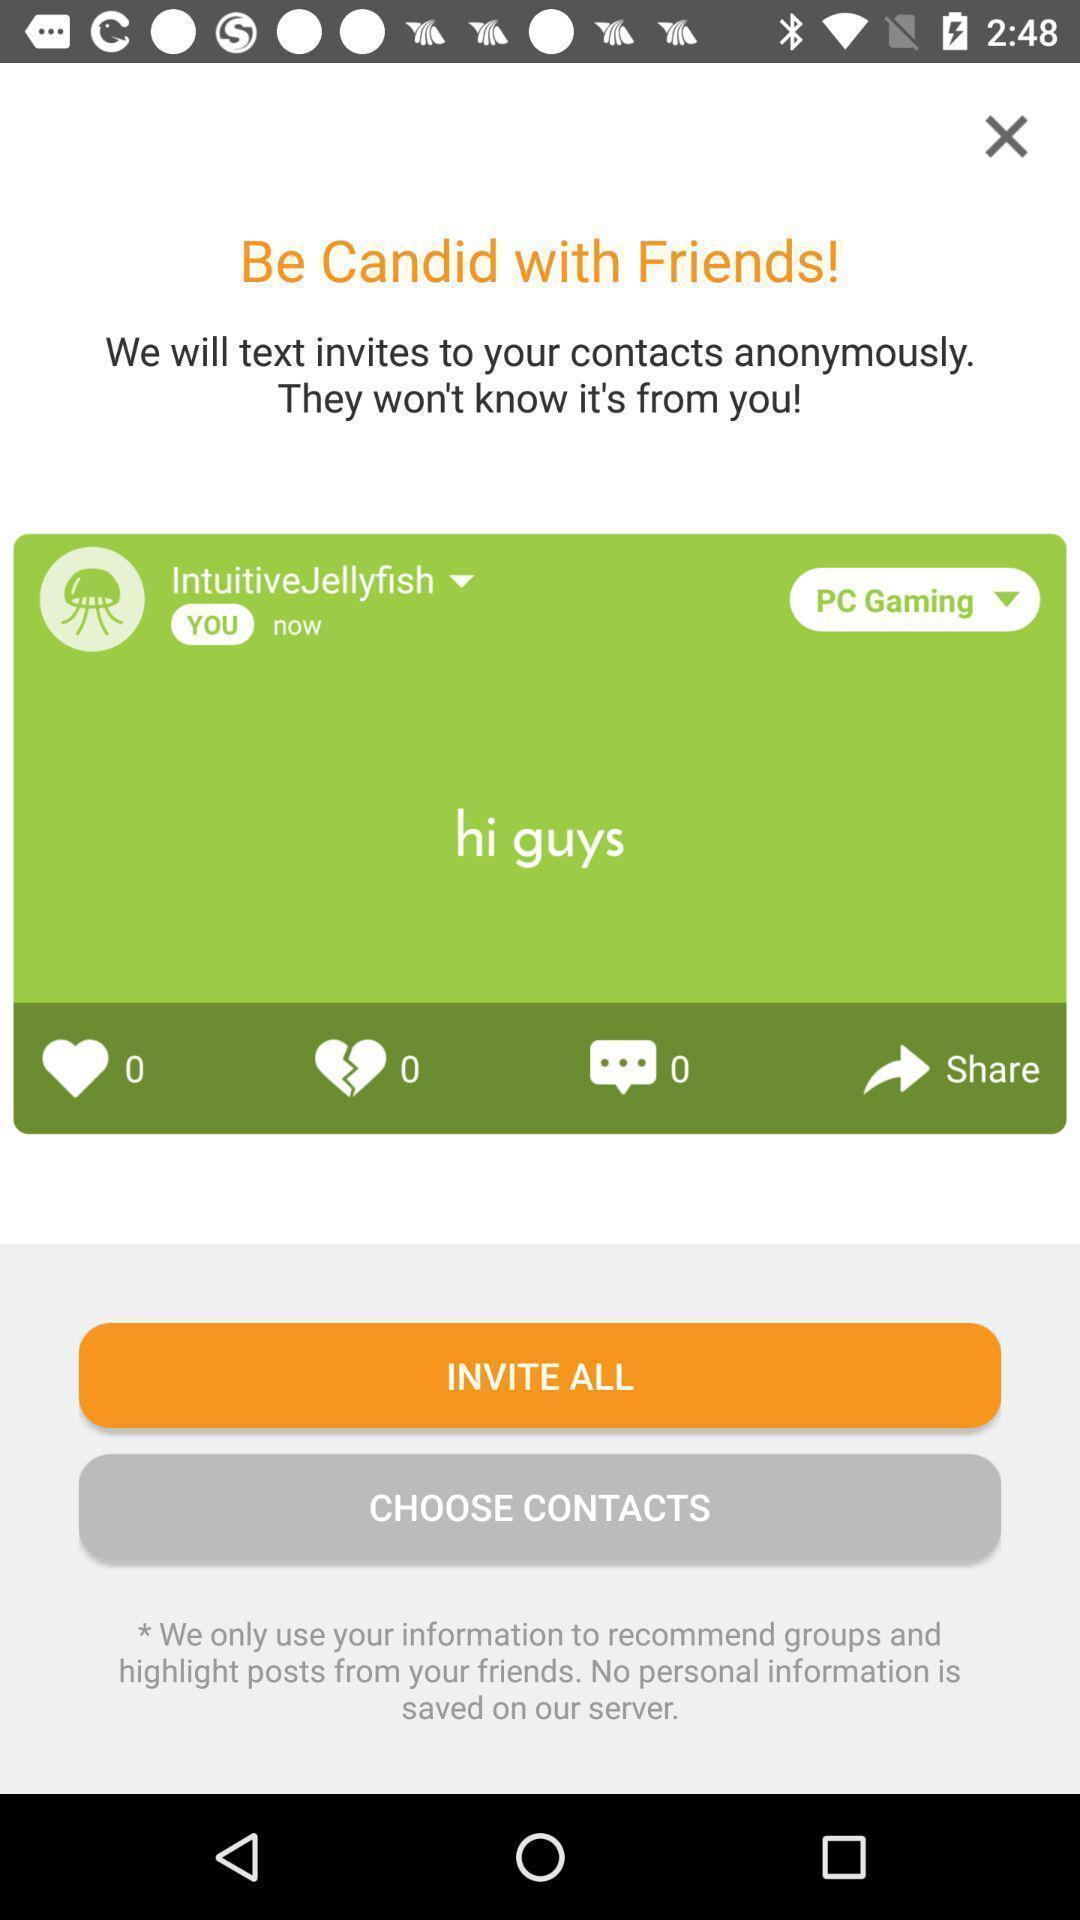Describe this image in words. Plage displaying to invite friends in a social application. 